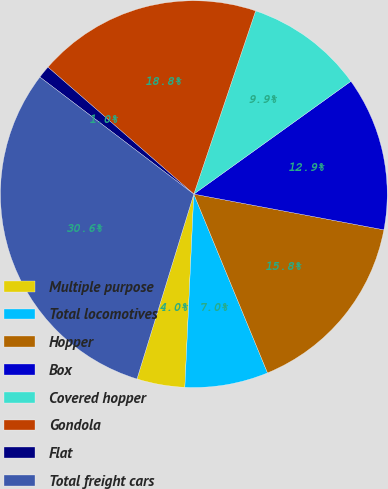Convert chart. <chart><loc_0><loc_0><loc_500><loc_500><pie_chart><fcel>Multiple purpose<fcel>Total locomotives<fcel>Hopper<fcel>Box<fcel>Covered hopper<fcel>Gondola<fcel>Flat<fcel>Total freight cars<nl><fcel>4.01%<fcel>6.96%<fcel>15.82%<fcel>12.87%<fcel>9.91%<fcel>18.78%<fcel>1.05%<fcel>30.6%<nl></chart> 